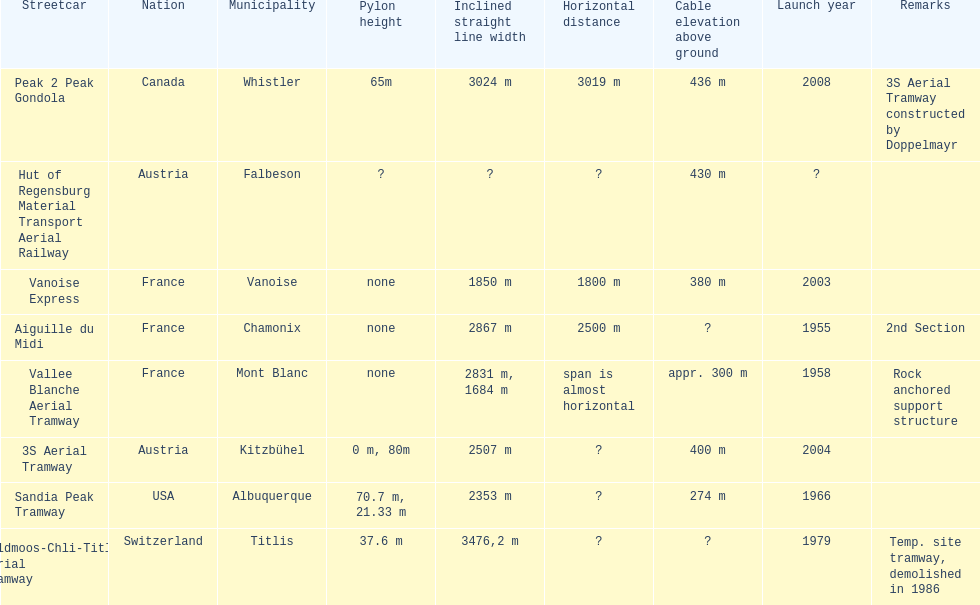How much longer is the peak 2 peak gondola than the 32 aerial tramway? 517. 